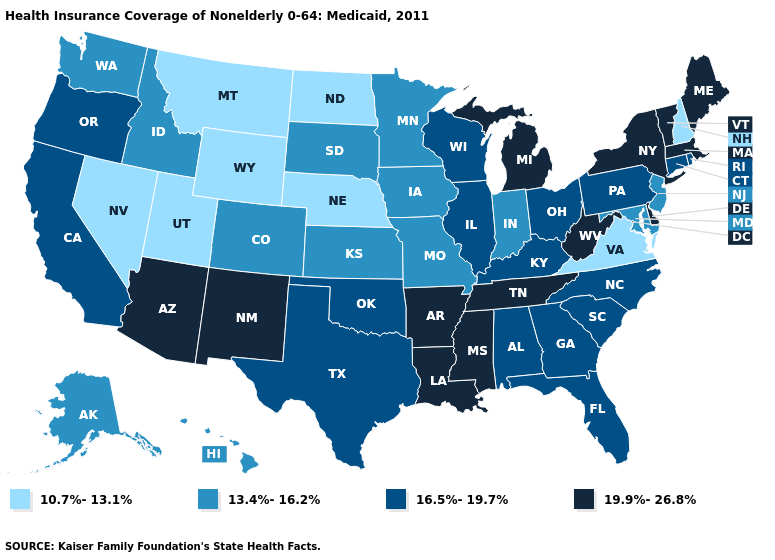What is the value of Ohio?
Write a very short answer. 16.5%-19.7%. Among the states that border Louisiana , does Arkansas have the highest value?
Quick response, please. Yes. Does Ohio have the lowest value in the USA?
Be succinct. No. What is the highest value in the USA?
Concise answer only. 19.9%-26.8%. What is the value of Virginia?
Short answer required. 10.7%-13.1%. Among the states that border Massachusetts , which have the highest value?
Short answer required. New York, Vermont. What is the value of Alabama?
Be succinct. 16.5%-19.7%. Among the states that border Vermont , does New Hampshire have the highest value?
Short answer required. No. Among the states that border Indiana , which have the lowest value?
Write a very short answer. Illinois, Kentucky, Ohio. Name the states that have a value in the range 16.5%-19.7%?
Be succinct. Alabama, California, Connecticut, Florida, Georgia, Illinois, Kentucky, North Carolina, Ohio, Oklahoma, Oregon, Pennsylvania, Rhode Island, South Carolina, Texas, Wisconsin. Name the states that have a value in the range 19.9%-26.8%?
Write a very short answer. Arizona, Arkansas, Delaware, Louisiana, Maine, Massachusetts, Michigan, Mississippi, New Mexico, New York, Tennessee, Vermont, West Virginia. Among the states that border South Carolina , which have the highest value?
Quick response, please. Georgia, North Carolina. What is the highest value in the USA?
Be succinct. 19.9%-26.8%. Which states have the highest value in the USA?
Answer briefly. Arizona, Arkansas, Delaware, Louisiana, Maine, Massachusetts, Michigan, Mississippi, New Mexico, New York, Tennessee, Vermont, West Virginia. Is the legend a continuous bar?
Answer briefly. No. 